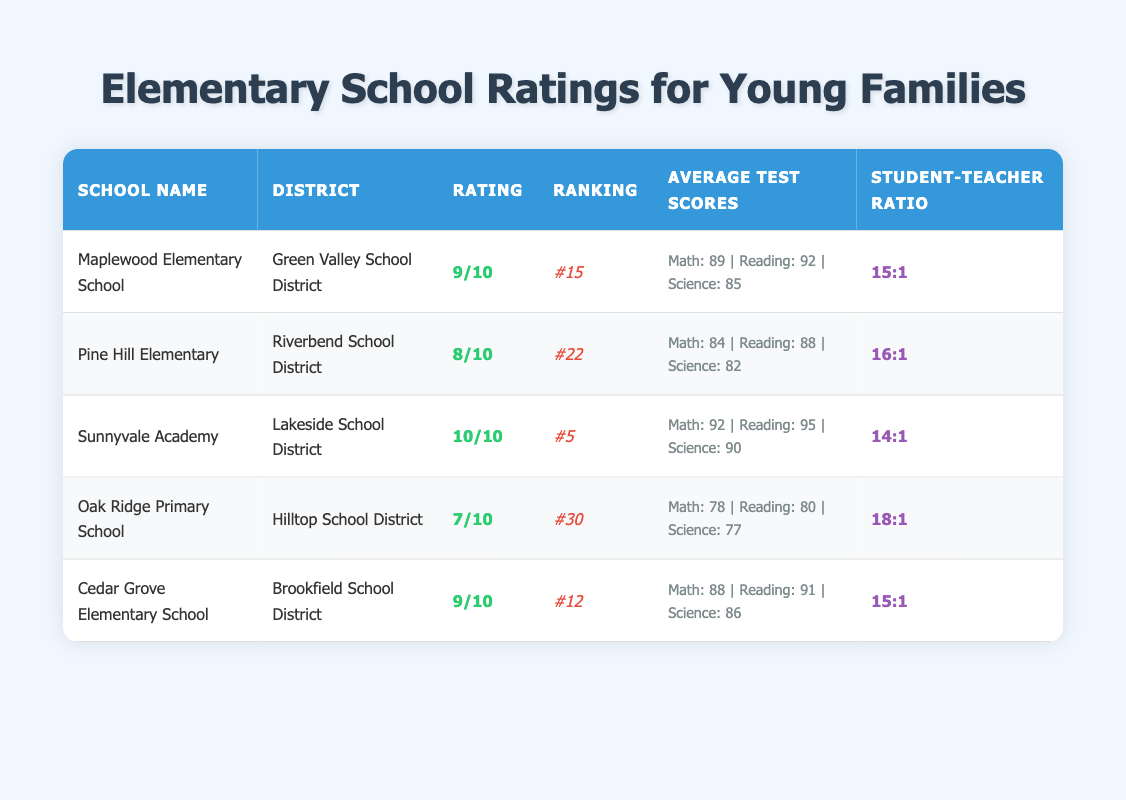What is the highest rating among the schools listed? To find the highest rating, I look at the 'Rating' column of the table. The highest value is 10, which corresponds to Sunnyvale Academy.
Answer: 10 Which school has the lowest ranking? I refer to the 'Ranking' column and identify that Oak Ridge Primary School has the lowest ranking at #30.
Answer: #30 What is the average student-teacher ratio for the schools listed? I add up the student-teacher ratios: 15, 16, 14, 18, and 15, which results in 78 total. Then I divide by 5 schools to find the average: 78 / 5 = 15.6, so rounding down gives a ratio of approximately 15:1.
Answer: 15:1 Is there a school with a rating of 7? I check the 'Rating' column and find that Oak Ridge Primary School has a rating of 7. Therefore, the statement is true.
Answer: Yes Which school has the best average scores across all subjects? I compare the average test scores for each school. Sunnyvale Academy has the highest scores in all subjects: Math (92), Reading (95), Science (90). Therefore, it has the best overall average.
Answer: Sunnyvale Academy What’s the total number of schools that have a rating of 9 or higher? I identify schools with ratings of 9 or higher by checking the 'Rating' column. Maplewood Elementary, Cedar Grove Elementary School, and Sunnyvale Academy meet this criterion, totaling three schools.
Answer: 3 Do all schools have a student-teacher ratio below 20:1? I check each school's ratio and find that Oak Ridge Primary School has a ratio of 18:1, which is below 20:1. Thus, all schools meet the condition.
Answer: Yes What is the combined average test score in Math for all schools? I sum the Math scores: 89 + 84 + 92 + 78 + 88 = 431, then divide by 5 schools to find the average: 431 / 5 = 86.2, rounding gives an average Math score of approximately 86.
Answer: 86 Which district has the school with the highest average test scores in Science? I look through the 'Average Test Scores' under the Science column. Sunnyvale Academy leads with a score of 90, which places it in the Lakeside School District.
Answer: Lakeside School District 